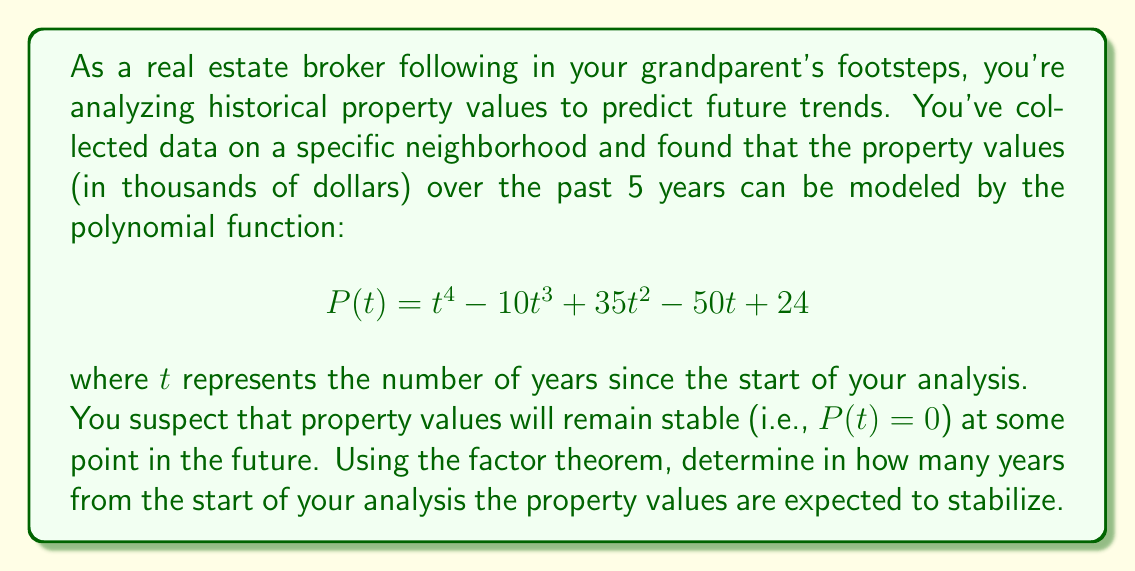Teach me how to tackle this problem. To solve this problem, we'll use the factor theorem, which states that a polynomial $P(t)$ has a factor $(t - r)$ if and only if $P(r) = 0$. We need to find the positive real root of the polynomial.

Let's approach this step-by-step:

1) First, let's check if there are any obvious factors. We can see that when $t = 1$:

   $P(1) = 1^4 - 10(1)^3 + 35(1)^2 - 50(1) + 24 = 1 - 10 + 35 - 50 + 24 = 0$

2) This means $(t - 1)$ is a factor of $P(t)$. We can factor it out:

   $P(t) = (t - 1)(t^3 - 9t^2 + 26t - 24)$

3) Now, we need to factor the cubic polynomial. Let's try rational root theorem. The possible rational roots are factors of 24: ±1, ±2, ±3, ±4, ±6, ±8, ±12, ±24.

4) Testing these, we find that $t = 2$ is also a root:

   $2^3 - 9(2)^2 + 26(2) - 24 = 8 - 36 + 52 - 24 = 0$

5) So we can factor further:

   $P(t) = (t - 1)(t - 2)(t^2 - 7t + 12)$

6) The quadratic factor can be solved using the quadratic formula or by recognizing it factors to $(t - 3)(t - 4)$.

7) Therefore, the complete factorization is:

   $P(t) = (t - 1)(t - 2)(t - 3)(t - 4)$

8) The roots of this polynomial are 1, 2, 3, and 4.

The question asks for the future point when property values stabilize, so we're looking for the positive root that's greater than the current time (t = 5). All roots are less than or equal to 4, which represents 4 years from the start of the analysis.

Since we're already 5 years into the analysis, there are no future points where $P(t) = 0$, meaning the property values are not expected to stabilize (reach zero) in the future according to this model.
Answer: Based on the given model, the property values are not expected to stabilize (reach zero) at any point in the future after the initial 5-year analysis period. 